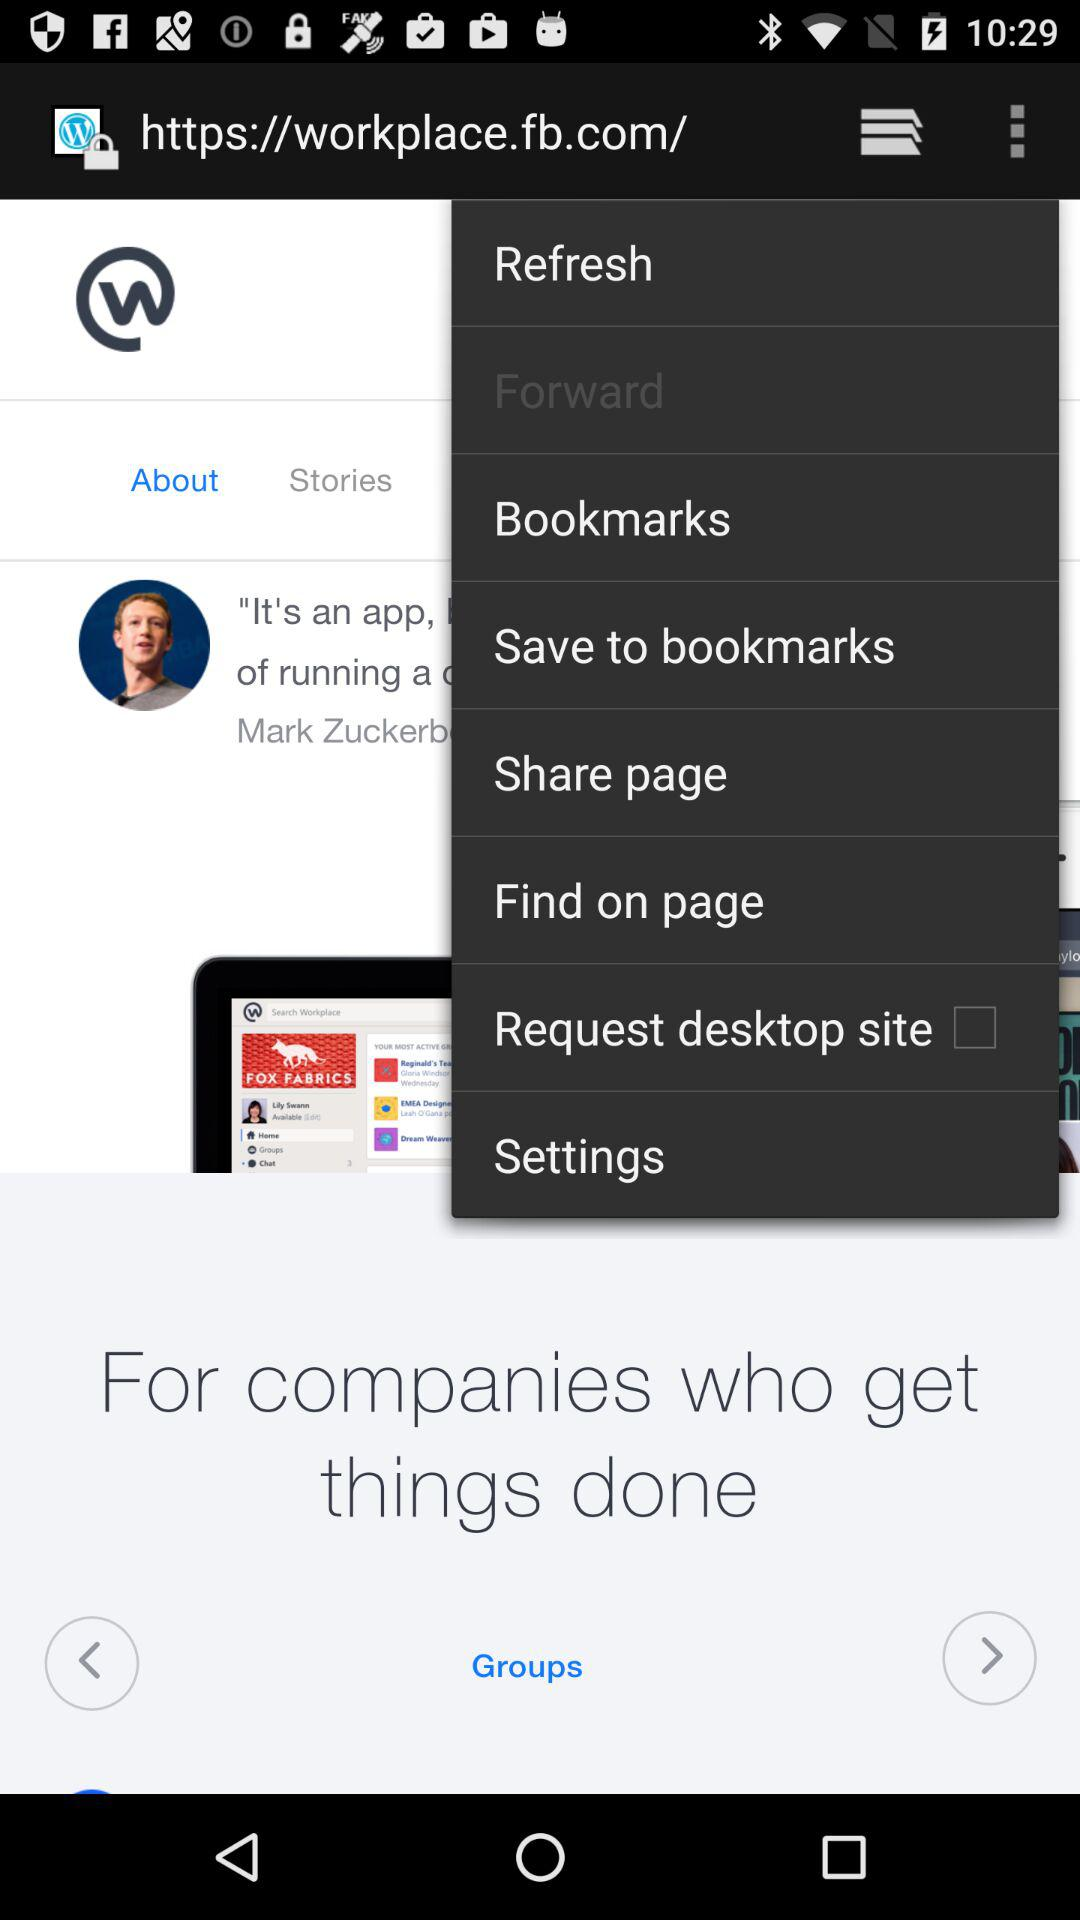What is the status of the "Request desktop site"? The status is "off". 